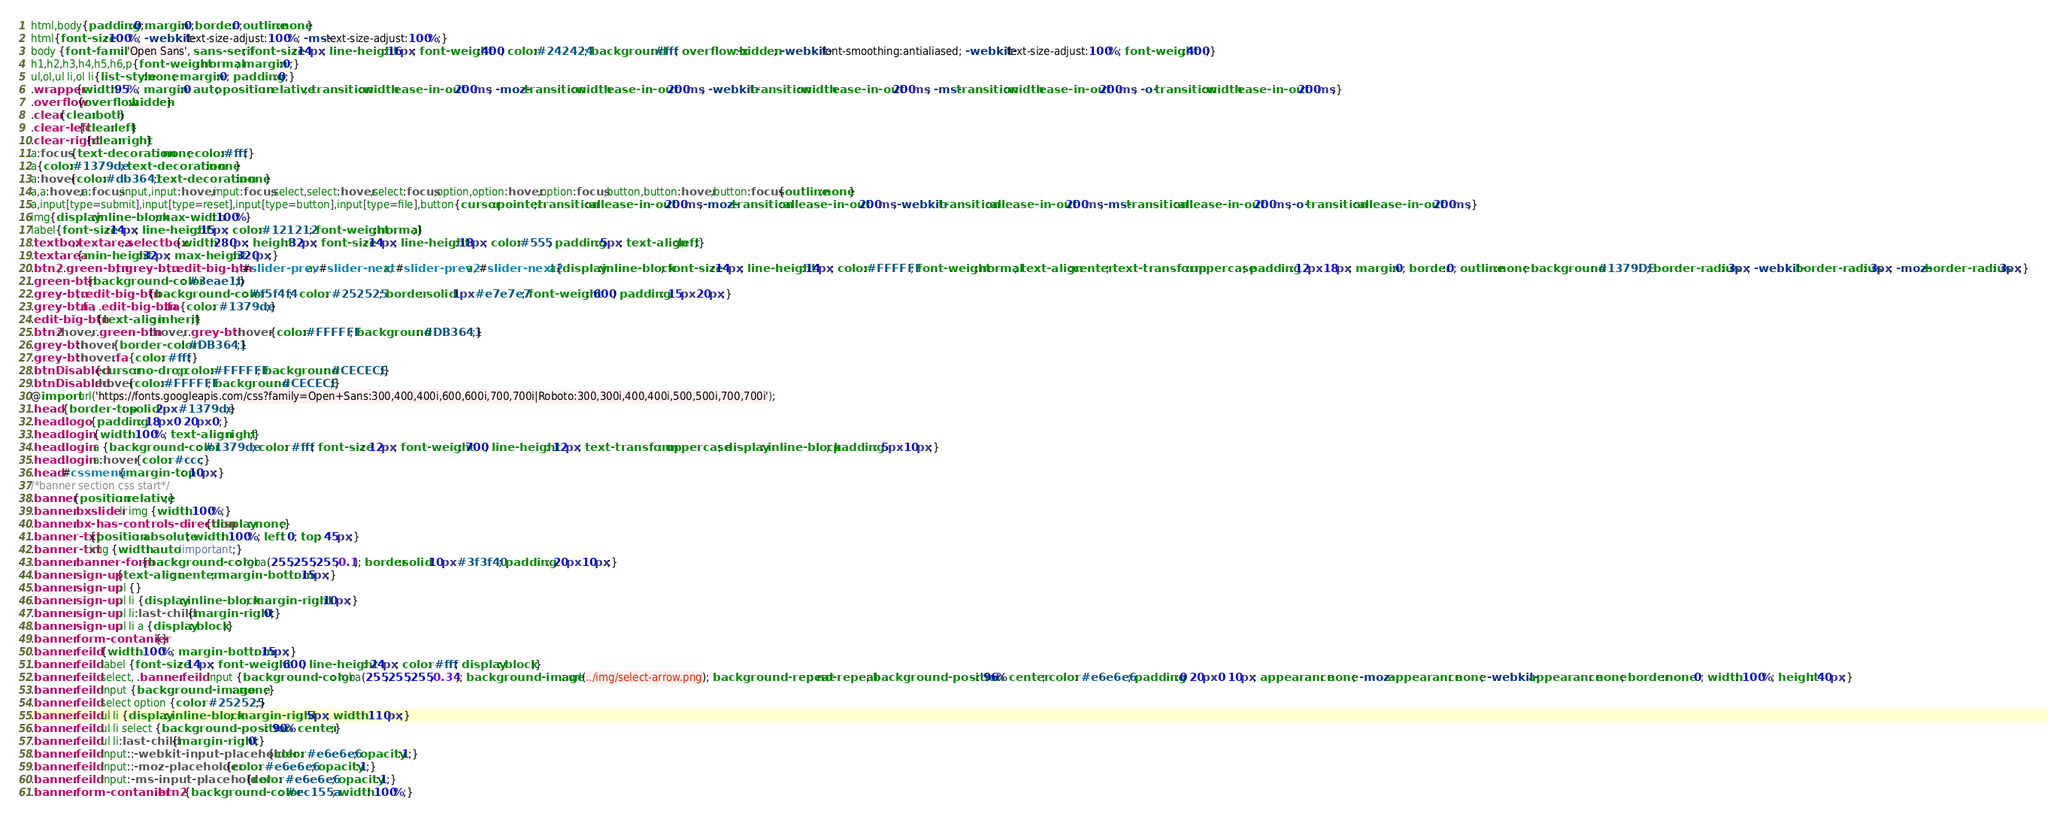<code> <loc_0><loc_0><loc_500><loc_500><_CSS_>html,body{padding:0;margin:0;border:0;outline:none}
html{font-size:100%; -webkit-text-size-adjust:100%; -ms-text-size-adjust:100%;}
body {font-family: 'Open Sans', sans-serif; font-size:14px; line-height:16px; font-weight:400; color:#242424; background:#fff; overflow-x:hidden; -webkit-font-smoothing:antialiased; -webkit-text-size-adjust:100%; font-weight:400;}
h1,h2,h3,h4,h5,h6,p{font-weight:normal; margin:0;}
ul,ol,ul li,ol li{list-style:none; margin:0; padding:0;}
.wrapper{width:95%; margin:0 auto; position:relative; transition:width ease-in-out 200ms; -moz-transition:width ease-in-out 200ms; -webkit-transition:width ease-in-out 200ms; -ms-transition:width ease-in-out 200ms; -o-transition:width ease-in-out 200ms;}
.overflow{overflow:hidden}
.clear{clear:both}
.clear-left{clear:left}
.clear-right{clear:right}
a:focus {text-decoration: none; color:#fff;}
a{color:#1379de; text-decoration:none}
a:hover{color:#db3641;text-decoration:none}
a,a:hover,a:focus,input,input:hover,input:focus,select,select:hover,select:focus,option,option:hover,option:focus,button,button:hover,button:focus{outline:none}
a,input[type=submit],input[type=reset],input[type=button],input[type=file],button{cursor:pointer;transition:all ease-in-out 200ms;-moz-transition:all ease-in-out 200ms;-webkit-transition:all ease-in-out 200ms;-ms-transition:all ease-in-out 200ms;-o-transition:all ease-in-out 200ms;}
img{display:inline-block;max-width:100%}
label{font-size:14px; line-height:15px; color:#121212; font-weight:normal;}
.textbox,.textarea,.selectbox{width:280px; height:32px; font-size:14px; line-height:18px; color:#555; padding:5px; text-align:left;}
.textarea{min-height:32px; max-height:320px;}
.btn2, .green-btn, .grey-btn, .edit-big-btn, #slider-prev a, #slider-next a, #slider-prev2 a, #slider-next2 a{display:inline-block; font-size:14px; line-height:14px; color:#FFFFFF; font-weight:normal; text-align:center; text-transform:uppercase; padding:12px 18px; margin:0; border:0; outline:none; background: #1379DE; border-radius: 3px; -webkit-border-radius: 3px; -moz-border-radius: 3px;}
.green-btn {background-color: #3eae1b;}
.grey-btn, .edit-big-btn {background-color: #f5f4f4;  color: #252525; border: solid 1px #e7e7e7; font-weight: 600; padding: 15px 20px;}
.grey-btn .fa, .edit-big-btn .fa {color: #1379de;}
.edit-big-btn {text-align: inherit;}
.btn2:hover, .green-btn:hover, .grey-btn:hover {color:#FFFFFF; background: #DB3641;}
.grey-btn:hover {border-color: #DB3641;}
.grey-btn:hover .fa {color: #fff;}
.btnDisabled{cursor:no-drop; color:#FFFFFF; background: #CECECE;}
.btnDisabled:hover{color:#FFFFFF; background: #CECECE;}
@import url('https://fonts.googleapis.com/css?family=Open+Sans:300,400,400i,600,600i,700,700i|Roboto:300,300i,400,400i,500,500i,700,700i');
.head {border-top: solid 2px #1379de;}
.head .logo {padding: 18px 0 20px 0;}
.head .login {width: 100%; text-align: right;}
.head .login a {background-color: #1379de; color: #fff; font-size: 12px; font-weight: 700; line-height: 12px; text-transform: uppercase; display: inline-block; padding: 5px 10px;}
.head .login a:hover {color: #ccc;}
.head #cssmenu {margin-top: 10px;}
/*banner section css start*/
.banner {position: relative;}
.banner .bxslider li img {width: 100%;}
.banner .bx-has-controls-direction {display: none;}
.banner-txt {position: absolute; width: 100%; left: 0; top: 45px;}
.banner-txt img {width: auto !important;}
.banner .banner-form {background-color: rgba(255,255,255,0.1); border:solid 10px #3f3f40; padding: 20px 10px;}
.banner .sign-up {text-align: center; margin-bottom: 15px;}
.banner .sign-up ul {}
.banner .sign-up ul li {display: inline-block; margin-right: 10px;}
.banner .sign-up ul li:last-child {margin-right: 0;}
.banner .sign-up ul li a {display: block;}
.banner .form-contanier {}
.banner .feild {width: 100%; margin-bottom: 15px;}
.banner .feild label {font-size: 14px; font-weight: 600; line-height: 24px; color: #fff; display: block;}
.banner .feild select, .banner .feild input {background-color: rgba(255,255,255,0.34); background-image: url(../img/select-arrow.png); background-repeat: no-repeat; background-position: 96% center; color: #e6e6e6; padding:0 20px 0 10px; appearance: none; -moz-appearance: none; -webkit-appearance: none; border:none 0; width: 100%; height: 40px;}
.banner .feild input {background-image: none;}
.banner .feild select option {color: #252525;}
.banner .feild ul li {display: inline-block; margin-right: 5px; width: 110px;}
.banner .feild ul li select {background-position: 90% center;}
.banner .feild ul li:last-child {margin-right: 0;}
.banner .feild input::-webkit-input-placeholder {color: #e6e6e6; opacity:1;}
.banner .feild input::-moz-placeholder {color: #e6e6e6; opacity:1;}
.banner .feild input:-ms-input-placeholder {color: #e6e6e6; opacity:1;}
.banner .form-contanier .btn2 {background-color: #ec155a; width: 100%;}</code> 